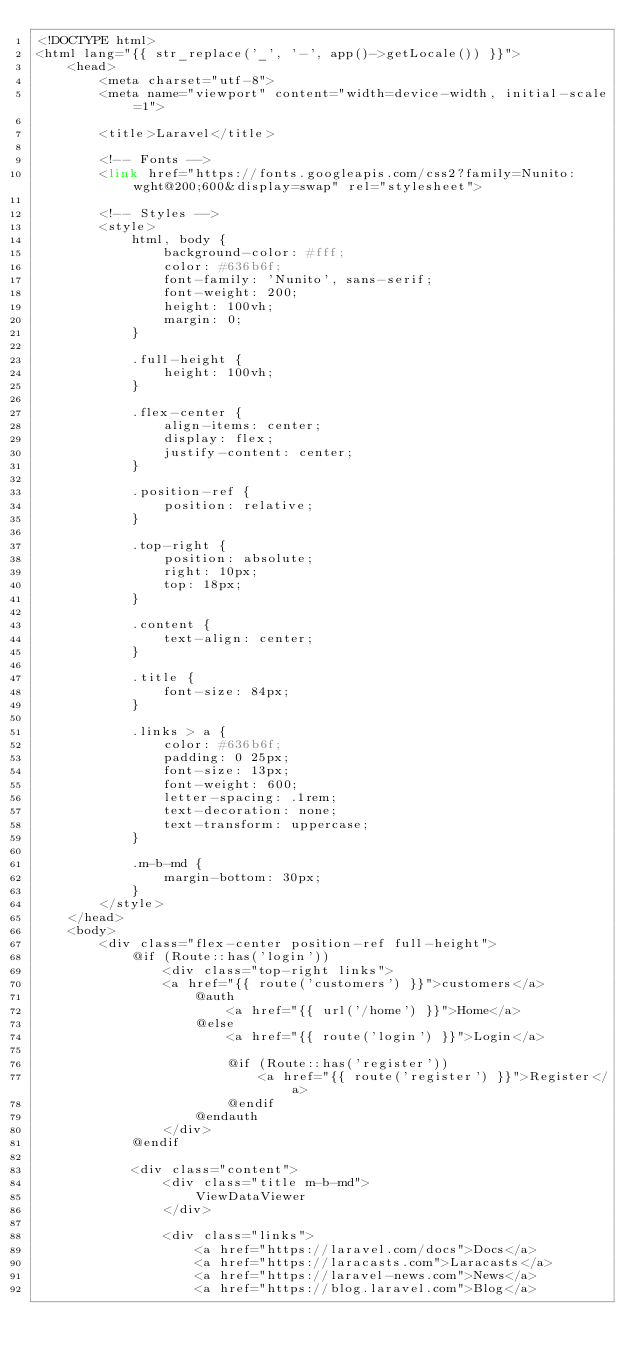Convert code to text. <code><loc_0><loc_0><loc_500><loc_500><_PHP_><!DOCTYPE html>
<html lang="{{ str_replace('_', '-', app()->getLocale()) }}">
    <head>
        <meta charset="utf-8">
        <meta name="viewport" content="width=device-width, initial-scale=1">

        <title>Laravel</title>

        <!-- Fonts -->
        <link href="https://fonts.googleapis.com/css2?family=Nunito:wght@200;600&display=swap" rel="stylesheet">

        <!-- Styles -->
        <style>
            html, body {
                background-color: #fff;
                color: #636b6f;
                font-family: 'Nunito', sans-serif;
                font-weight: 200;
                height: 100vh;
                margin: 0;
            }

            .full-height {
                height: 100vh;
            }

            .flex-center {
                align-items: center;
                display: flex;
                justify-content: center;
            }

            .position-ref {
                position: relative;
            }

            .top-right {
                position: absolute;
                right: 10px;
                top: 18px;
            }

            .content {
                text-align: center;
            }

            .title {
                font-size: 84px;
            }

            .links > a {
                color: #636b6f;
                padding: 0 25px;
                font-size: 13px;
                font-weight: 600;
                letter-spacing: .1rem;
                text-decoration: none;
                text-transform: uppercase;
            }

            .m-b-md {
                margin-bottom: 30px;
            }
        </style>
    </head>
    <body>
        <div class="flex-center position-ref full-height">
            @if (Route::has('login'))
                <div class="top-right links">
                <a href="{{ route('customers') }}">customers</a>
                    @auth
                        <a href="{{ url('/home') }}">Home</a>
                    @else
                        <a href="{{ route('login') }}">Login</a>

                        @if (Route::has('register'))
                            <a href="{{ route('register') }}">Register</a>
                        @endif
                    @endauth
                </div>
            @endif

            <div class="content">
                <div class="title m-b-md">
                    ViewDataViewer
                </div>

                <div class="links">
                    <a href="https://laravel.com/docs">Docs</a>
                    <a href="https://laracasts.com">Laracasts</a>
                    <a href="https://laravel-news.com">News</a>
                    <a href="https://blog.laravel.com">Blog</a></code> 